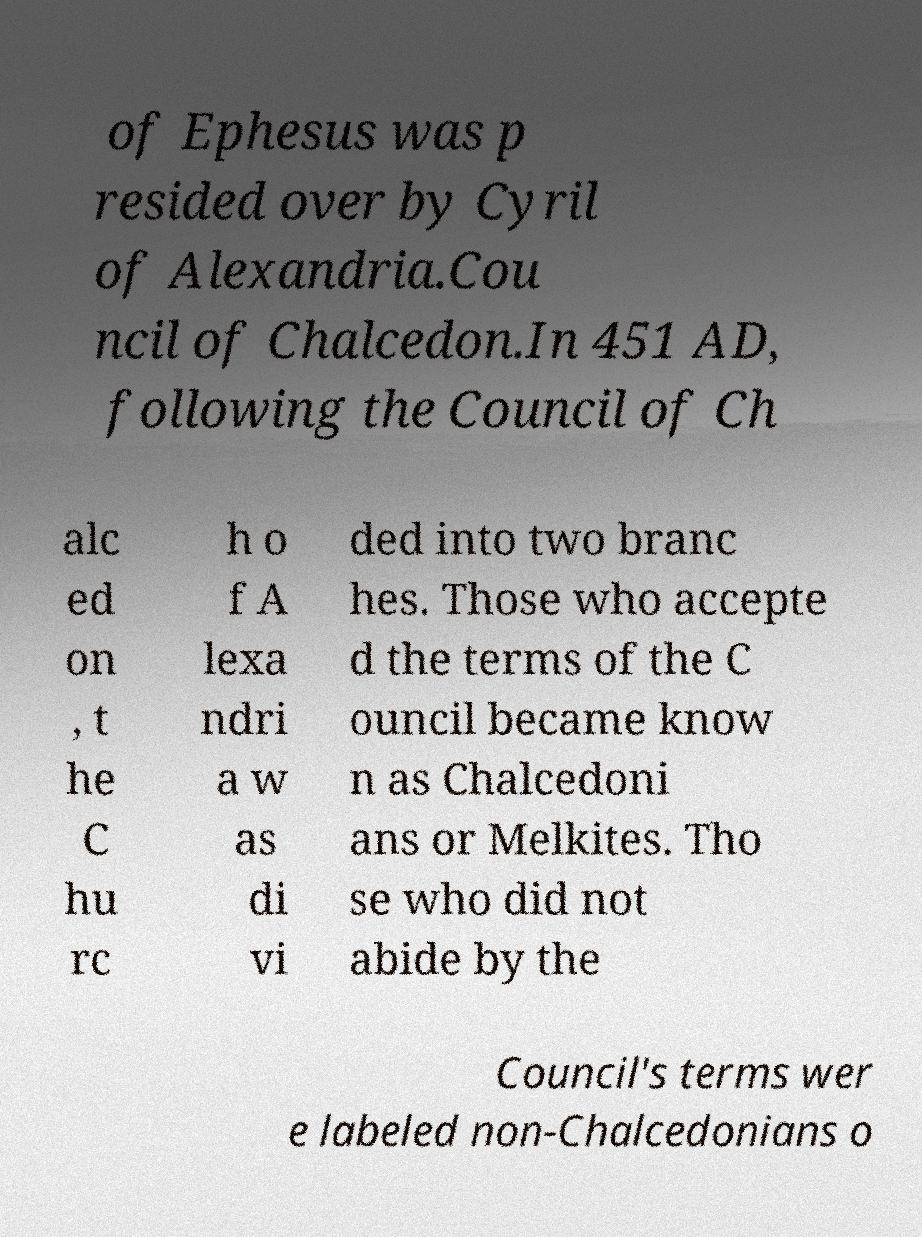What messages or text are displayed in this image? I need them in a readable, typed format. of Ephesus was p resided over by Cyril of Alexandria.Cou ncil of Chalcedon.In 451 AD, following the Council of Ch alc ed on , t he C hu rc h o f A lexa ndri a w as di vi ded into two branc hes. Those who accepte d the terms of the C ouncil became know n as Chalcedoni ans or Melkites. Tho se who did not abide by the Council's terms wer e labeled non-Chalcedonians o 